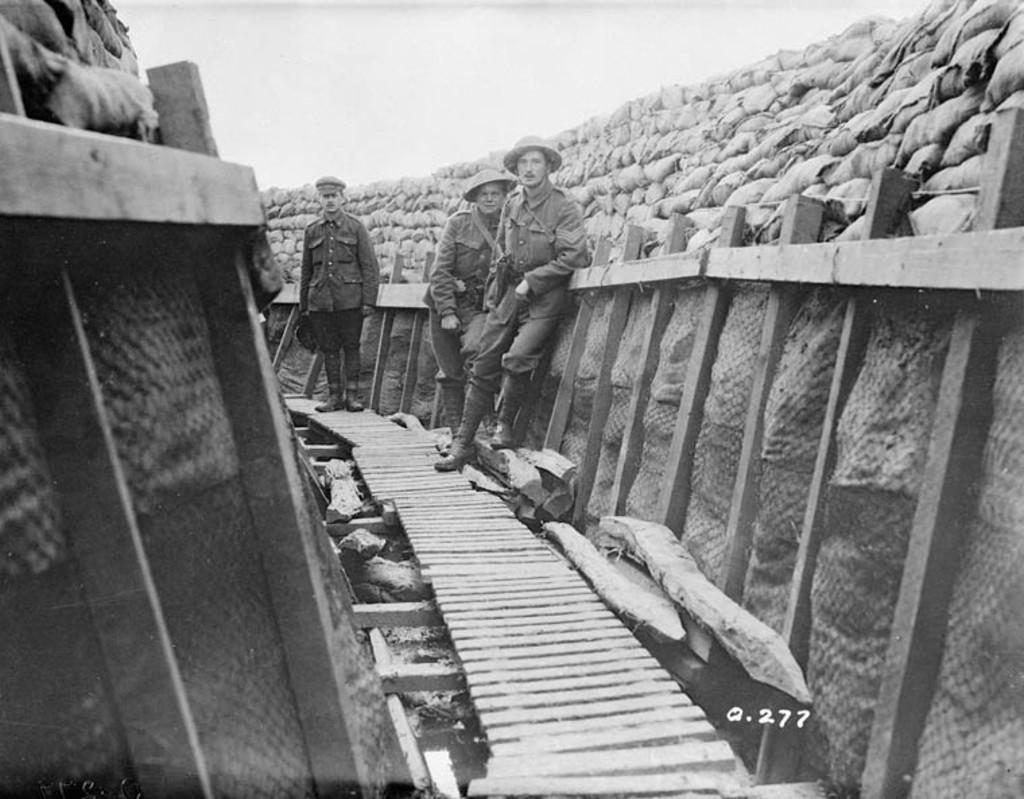Could you give a brief overview of what you see in this image? In this black and white picture there are three men standing. In the center there is a path. There is a railing on the either sides of the path. Behind the railing there are sacks. At the top there is the sky. 